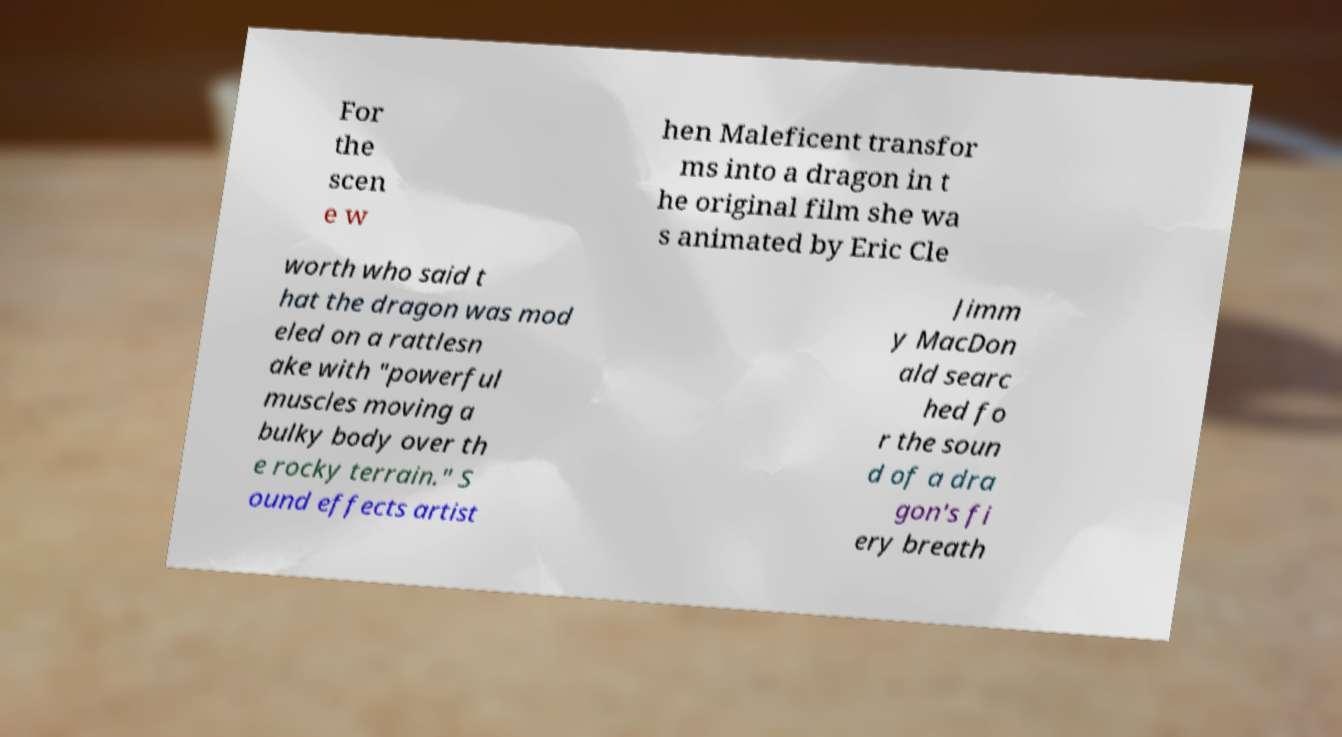I need the written content from this picture converted into text. Can you do that? For the scen e w hen Maleficent transfor ms into a dragon in t he original film she wa s animated by Eric Cle worth who said t hat the dragon was mod eled on a rattlesn ake with "powerful muscles moving a bulky body over th e rocky terrain." S ound effects artist Jimm y MacDon ald searc hed fo r the soun d of a dra gon's fi ery breath 